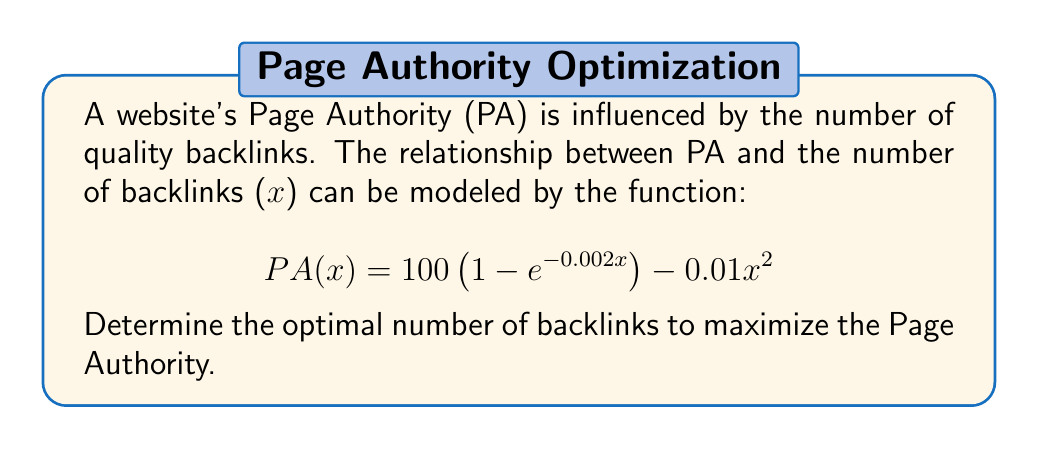Provide a solution to this math problem. To find the optimal number of backlinks, we need to find the maximum value of the PA function. This can be done by following these steps:

1. Take the derivative of PA(x) with respect to x:
   $$\frac{d}{dx}PA(x) = 100(0.002e^{-0.002x}) - 0.02x$$

2. Set the derivative equal to zero to find the critical point:
   $$0.2e^{-0.002x} - 0.02x = 0$$

3. This equation cannot be solved algebraically, so we need to use numerical methods. Using a graphing calculator or computer software, we can find that the solution is approximately:
   $$x \approx 69.31$$

4. To confirm this is a maximum, we can check the second derivative:
   $$\frac{d^2}{dx^2}PA(x) = -0.0004e^{-0.002x} - 0.02$$
   
   At x = 69.31, this is negative, confirming a maximum.

5. Since we're dealing with backlinks, we need to round to the nearest whole number:
   $$x = 69$$

Therefore, the optimal number of backlinks to maximize Page Authority is 69.
Answer: 69 backlinks 